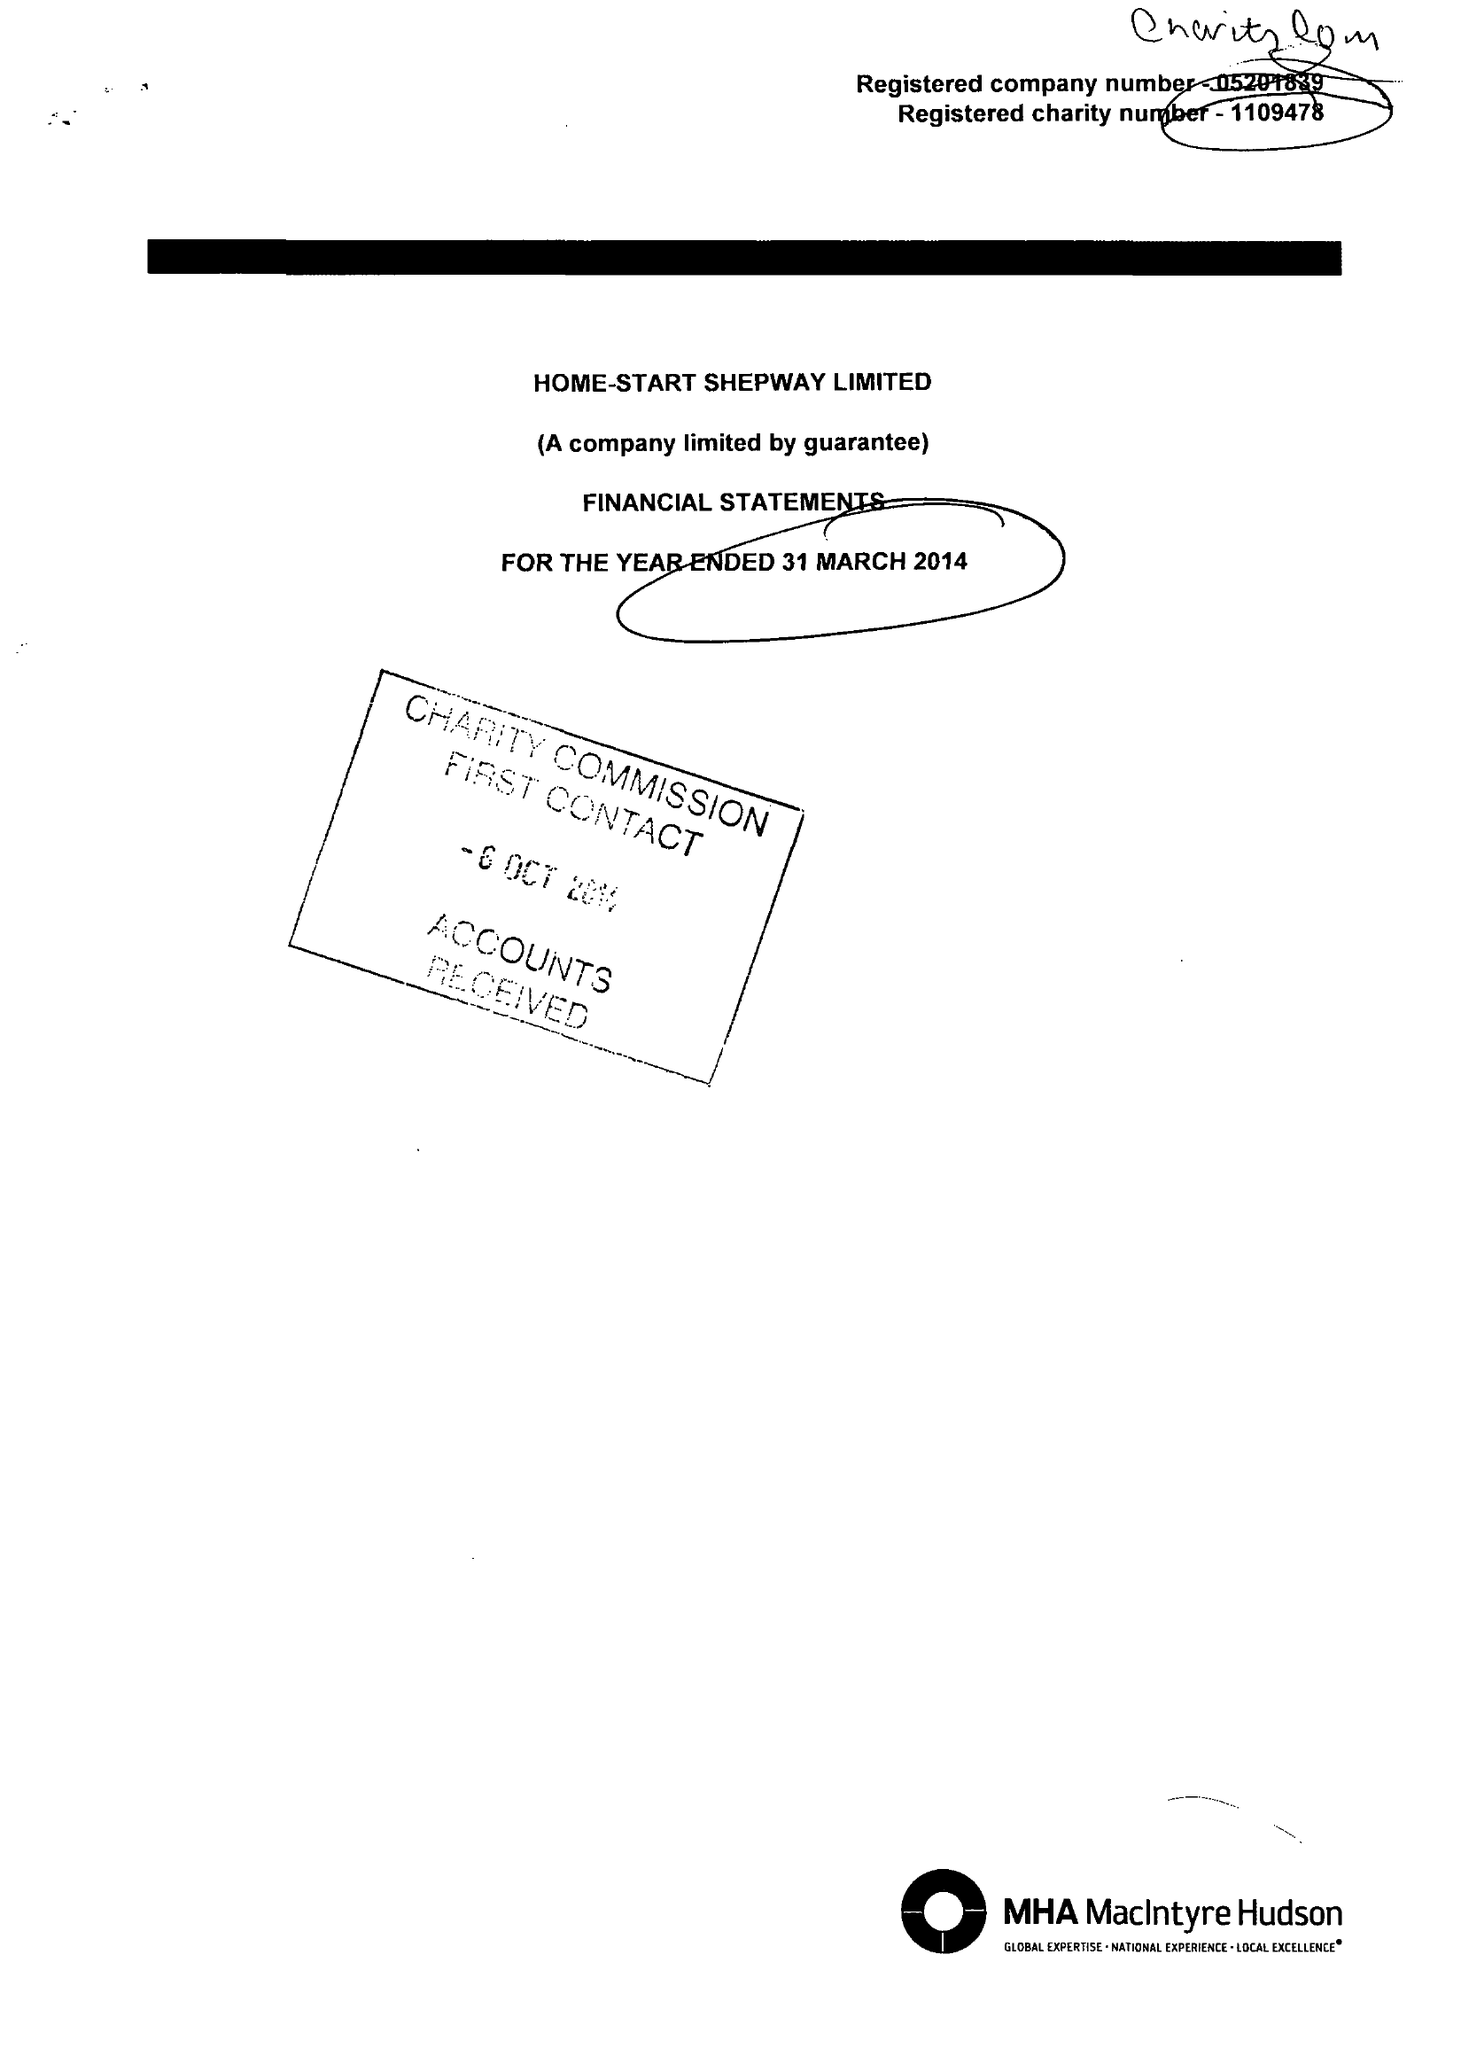What is the value for the charity_name?
Answer the question using a single word or phrase. Home-Start Shepway Ltd. 